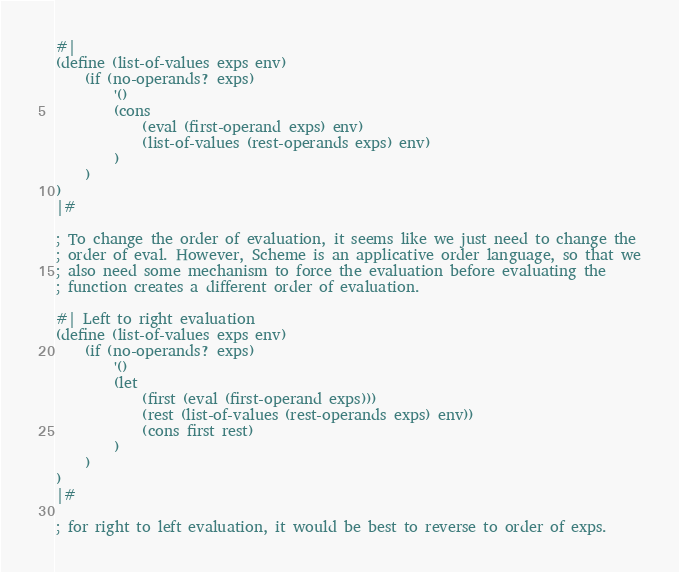<code> <loc_0><loc_0><loc_500><loc_500><_Scheme_>#|
(define (list-of-values exps env)
    (if (no-operands? exps)
        '()
        (cons 
            (eval (first-operand exps) env)
            (list-of-values (rest-operands exps) env)
        )
    )
)
|#

; To change the order of evaluation, it seems like we just need to change the
; order of eval. However, Scheme is an applicative order language, so that we
; also need some mechanism to force the evaluation before evaluating the
; function creates a different order of evaluation.

#| Left to right evaluation
(define (list-of-values exps env)
    (if (no-operands? exps)
        '()
        (let
            (first (eval (first-operand exps)))
            (rest (list-of-values (rest-operands exps) env))
            (cons first rest)
        )
    )
)
|#

; for right to left evaluation, it would be best to reverse to order of exps.
</code> 